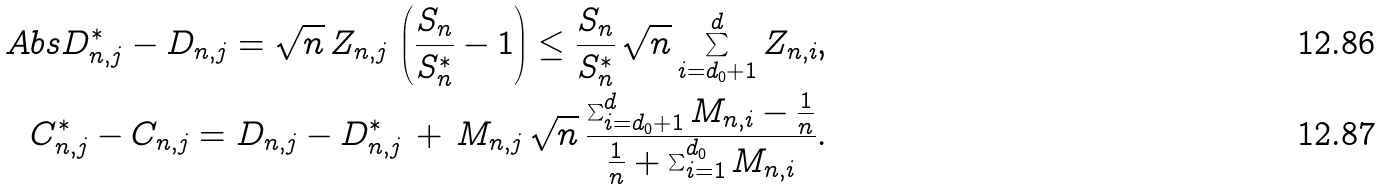<formula> <loc_0><loc_0><loc_500><loc_500>\ A b s { D _ { n , j } ^ { * } - D _ { n , j } } = \sqrt { n } \, Z _ { n , j } \, \left ( \frac { S _ { n } } { S _ { n } ^ { * } } - 1 \right ) \leq \frac { S _ { n } } { S _ { n } ^ { * } } \, \sqrt { n } \sum _ { i = d _ { 0 } + 1 } ^ { d } Z _ { n , i } , \\ C _ { n , j } ^ { * } - C _ { n , j } = D _ { n , j } - D _ { n , j } ^ { * } \, + \, M _ { n , j } \, \sqrt { n } \, \frac { \sum _ { i = d _ { 0 } + 1 } ^ { d } M _ { n , i } - \frac { 1 } { n } } { \frac { 1 } { n } + \sum _ { i = 1 } ^ { d _ { 0 } } M _ { n , i } } .</formula> 